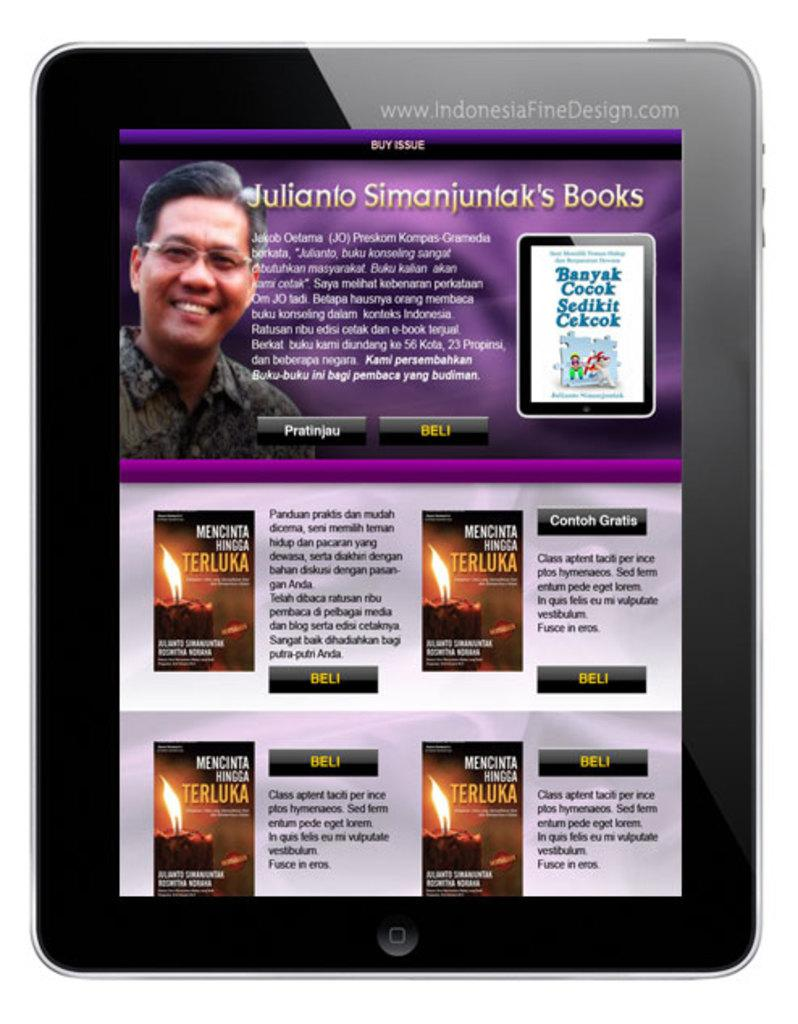What device is visible in the image? There is a tablet in the image. What is displayed on the tablet? A poster is displayed on the tablet. Can you describe the man in the poster? The man in the poster is wearing spectacles and smiling. What else can be seen on the poster besides the man? There is text written on the poster. What type of creature is standing next to the scarecrow in the image? There is no creature or scarecrow present in the image; it features a tablet displaying a poster with a man wearing spectacles and smiling. How does the man in the poster look at the scarecrow? There is no scarecrow present in the image, so the man in the poster cannot be looking at one. 